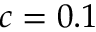Convert formula to latex. <formula><loc_0><loc_0><loc_500><loc_500>c = 0 . 1</formula> 